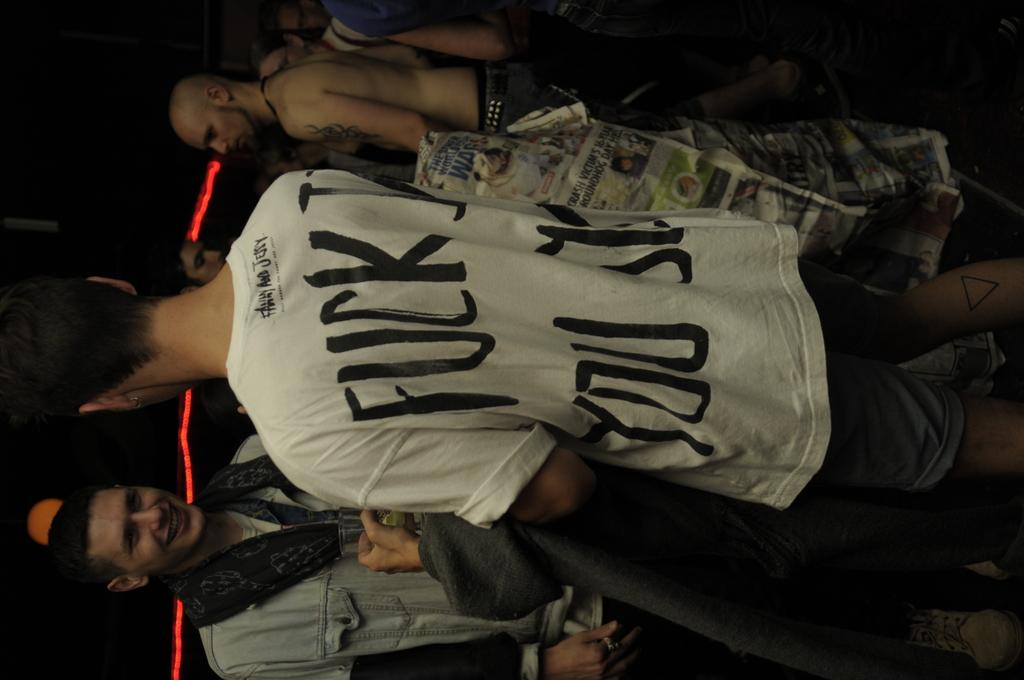What is the main subject of the image? The main subject of the image is a group of people standing. What type of medium is the image presented in? The image appears to be a newspaper. Is there any specific color present in the image? Yes, there is a red light in the image. How would you describe the overall lighting in the image? The background of the image is dark. How many crows are sitting on the tray in the image? There are no crows or trays present in the image. What type of club is featured in the image? There is no club featured in the image; it primarily shows a group of people standing. 